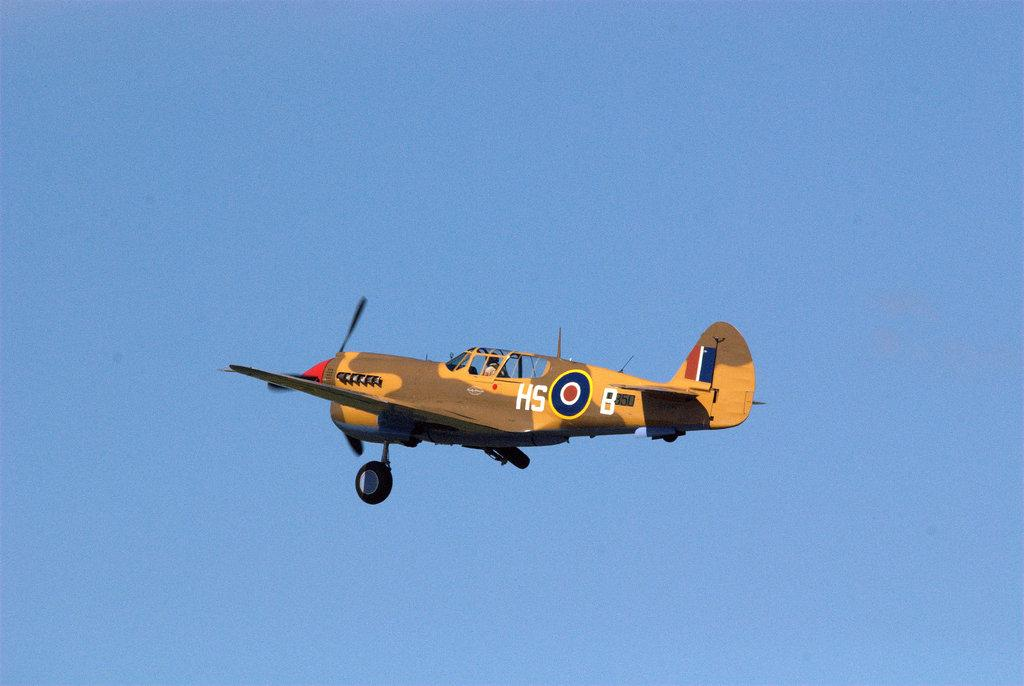What is the main subject of the image? The main subject of the image is a person sitting inside the plane. Where is the person located in the image? The person is in the middle of the image. What can be seen in the background of the image? The sky is visible in the background of the image. What type of boot is the person wearing in the image? There is no boot visible in the image, as the person is sitting inside a plane. Are there any pets visible in the image? No, there are no pets present in the image. 